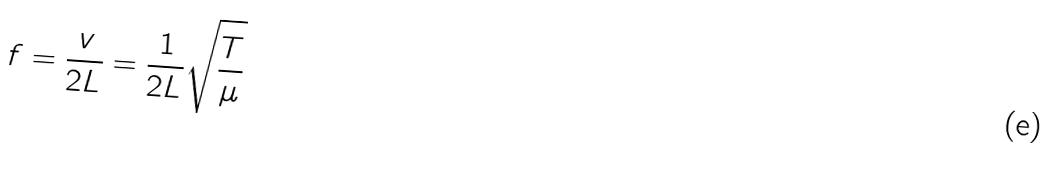<formula> <loc_0><loc_0><loc_500><loc_500>f = \frac { v } { 2 L } = \frac { 1 } { 2 L } \sqrt { \frac { T } { \mu } }</formula> 